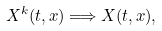<formula> <loc_0><loc_0><loc_500><loc_500>X ^ { k } ( t , x ) \Longrightarrow X ( t , x ) ,</formula> 